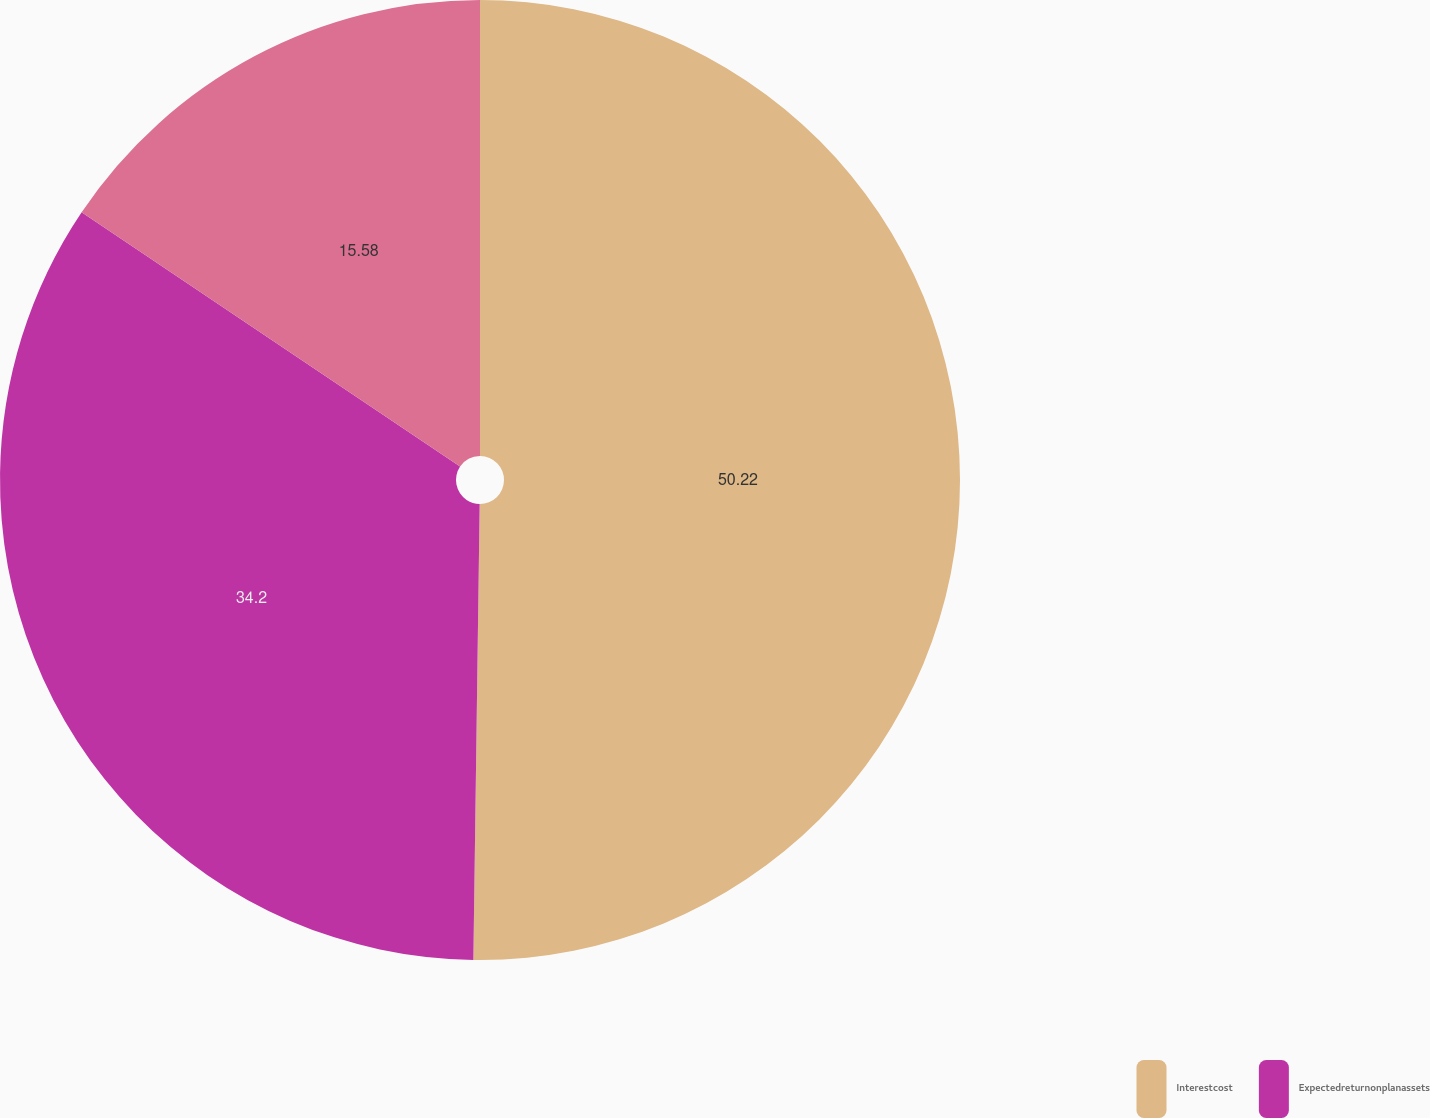Convert chart. <chart><loc_0><loc_0><loc_500><loc_500><pie_chart><fcel>Interestcost<fcel>Expectedreturnonplanassets<fcel>Unnamed: 2<nl><fcel>50.22%<fcel>34.2%<fcel>15.58%<nl></chart> 